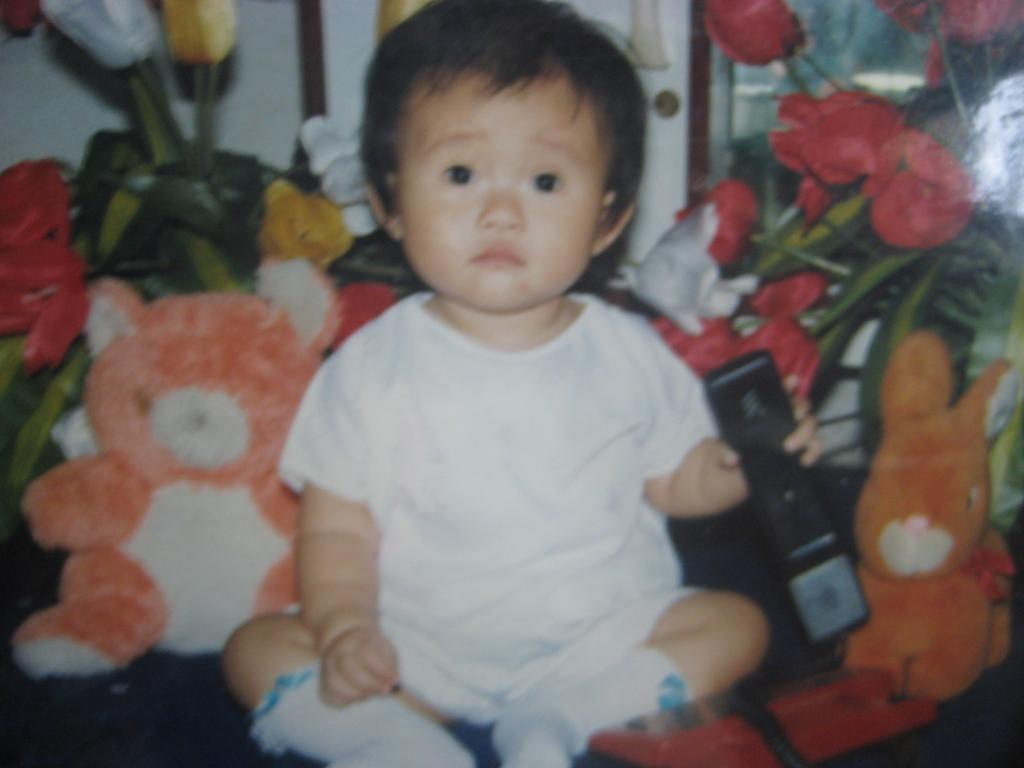What is the kid doing in the image? The kid is sitting in the image. What is the kid holding in the image? The kid is holding an object. What other objects are present in the image? There are dolls in the image. What can be seen in the background of the image? There are plants, flowers, and a wall visible in the background. How much payment is the kid receiving for their performance on stage in the image? There is no stage or performance present in the image, and no payment is being made. How many brothers does the kid have in the image? There is no information about the kid's family or siblings in the image. 